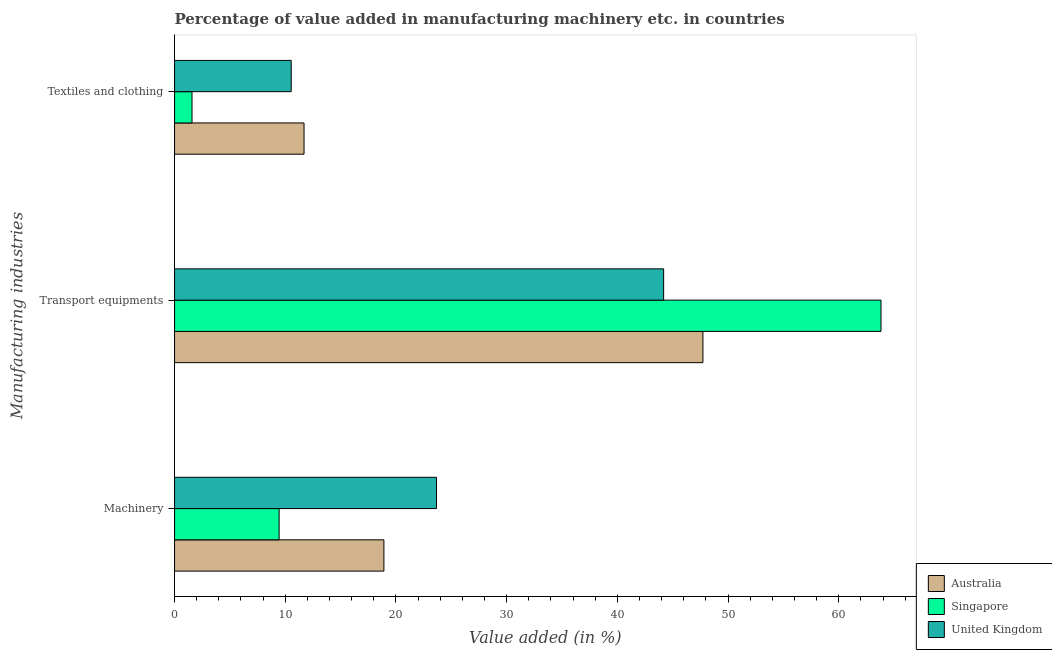How many different coloured bars are there?
Your answer should be compact. 3. How many groups of bars are there?
Provide a short and direct response. 3. How many bars are there on the 1st tick from the top?
Provide a short and direct response. 3. How many bars are there on the 1st tick from the bottom?
Your answer should be compact. 3. What is the label of the 1st group of bars from the top?
Offer a very short reply. Textiles and clothing. What is the value added in manufacturing machinery in United Kingdom?
Give a very brief answer. 23.66. Across all countries, what is the maximum value added in manufacturing textile and clothing?
Offer a very short reply. 11.7. Across all countries, what is the minimum value added in manufacturing transport equipments?
Offer a very short reply. 44.18. What is the total value added in manufacturing transport equipments in the graph?
Provide a short and direct response. 155.71. What is the difference between the value added in manufacturing machinery in Singapore and that in Australia?
Your answer should be compact. -9.47. What is the difference between the value added in manufacturing transport equipments in Singapore and the value added in manufacturing machinery in United Kingdom?
Ensure brevity in your answer.  40.15. What is the average value added in manufacturing transport equipments per country?
Your answer should be compact. 51.9. What is the difference between the value added in manufacturing textile and clothing and value added in manufacturing transport equipments in Singapore?
Your response must be concise. -62.23. What is the ratio of the value added in manufacturing machinery in Australia to that in United Kingdom?
Provide a short and direct response. 0.8. Is the value added in manufacturing transport equipments in Singapore less than that in United Kingdom?
Your answer should be very brief. No. What is the difference between the highest and the second highest value added in manufacturing textile and clothing?
Your response must be concise. 1.16. What is the difference between the highest and the lowest value added in manufacturing transport equipments?
Keep it short and to the point. 19.63. Is it the case that in every country, the sum of the value added in manufacturing machinery and value added in manufacturing transport equipments is greater than the value added in manufacturing textile and clothing?
Give a very brief answer. Yes. How many countries are there in the graph?
Make the answer very short. 3. Does the graph contain grids?
Make the answer very short. No. How many legend labels are there?
Give a very brief answer. 3. How are the legend labels stacked?
Provide a short and direct response. Vertical. What is the title of the graph?
Your response must be concise. Percentage of value added in manufacturing machinery etc. in countries. Does "Italy" appear as one of the legend labels in the graph?
Make the answer very short. No. What is the label or title of the X-axis?
Offer a terse response. Value added (in %). What is the label or title of the Y-axis?
Keep it short and to the point. Manufacturing industries. What is the Value added (in %) of Australia in Machinery?
Provide a succinct answer. 18.91. What is the Value added (in %) in Singapore in Machinery?
Offer a very short reply. 9.44. What is the Value added (in %) of United Kingdom in Machinery?
Make the answer very short. 23.66. What is the Value added (in %) of Australia in Transport equipments?
Give a very brief answer. 47.73. What is the Value added (in %) of Singapore in Transport equipments?
Give a very brief answer. 63.81. What is the Value added (in %) of United Kingdom in Transport equipments?
Offer a very short reply. 44.18. What is the Value added (in %) in Australia in Textiles and clothing?
Your response must be concise. 11.7. What is the Value added (in %) of Singapore in Textiles and clothing?
Offer a very short reply. 1.58. What is the Value added (in %) in United Kingdom in Textiles and clothing?
Your answer should be very brief. 10.54. Across all Manufacturing industries, what is the maximum Value added (in %) of Australia?
Your response must be concise. 47.73. Across all Manufacturing industries, what is the maximum Value added (in %) of Singapore?
Your response must be concise. 63.81. Across all Manufacturing industries, what is the maximum Value added (in %) of United Kingdom?
Your answer should be very brief. 44.18. Across all Manufacturing industries, what is the minimum Value added (in %) in Australia?
Give a very brief answer. 11.7. Across all Manufacturing industries, what is the minimum Value added (in %) in Singapore?
Your answer should be very brief. 1.58. Across all Manufacturing industries, what is the minimum Value added (in %) of United Kingdom?
Ensure brevity in your answer.  10.54. What is the total Value added (in %) of Australia in the graph?
Make the answer very short. 78.33. What is the total Value added (in %) in Singapore in the graph?
Provide a short and direct response. 74.83. What is the total Value added (in %) in United Kingdom in the graph?
Provide a short and direct response. 78.37. What is the difference between the Value added (in %) of Australia in Machinery and that in Transport equipments?
Your answer should be compact. -28.81. What is the difference between the Value added (in %) in Singapore in Machinery and that in Transport equipments?
Provide a short and direct response. -54.37. What is the difference between the Value added (in %) in United Kingdom in Machinery and that in Transport equipments?
Make the answer very short. -20.52. What is the difference between the Value added (in %) in Australia in Machinery and that in Textiles and clothing?
Provide a succinct answer. 7.22. What is the difference between the Value added (in %) in Singapore in Machinery and that in Textiles and clothing?
Keep it short and to the point. 7.87. What is the difference between the Value added (in %) in United Kingdom in Machinery and that in Textiles and clothing?
Offer a terse response. 13.12. What is the difference between the Value added (in %) of Australia in Transport equipments and that in Textiles and clothing?
Offer a terse response. 36.03. What is the difference between the Value added (in %) of Singapore in Transport equipments and that in Textiles and clothing?
Make the answer very short. 62.23. What is the difference between the Value added (in %) in United Kingdom in Transport equipments and that in Textiles and clothing?
Your answer should be very brief. 33.64. What is the difference between the Value added (in %) in Australia in Machinery and the Value added (in %) in Singapore in Transport equipments?
Offer a very short reply. -44.9. What is the difference between the Value added (in %) of Australia in Machinery and the Value added (in %) of United Kingdom in Transport equipments?
Ensure brevity in your answer.  -25.27. What is the difference between the Value added (in %) of Singapore in Machinery and the Value added (in %) of United Kingdom in Transport equipments?
Offer a very short reply. -34.73. What is the difference between the Value added (in %) in Australia in Machinery and the Value added (in %) in Singapore in Textiles and clothing?
Your answer should be compact. 17.33. What is the difference between the Value added (in %) of Australia in Machinery and the Value added (in %) of United Kingdom in Textiles and clothing?
Make the answer very short. 8.37. What is the difference between the Value added (in %) of Singapore in Machinery and the Value added (in %) of United Kingdom in Textiles and clothing?
Your answer should be compact. -1.09. What is the difference between the Value added (in %) in Australia in Transport equipments and the Value added (in %) in Singapore in Textiles and clothing?
Provide a short and direct response. 46.15. What is the difference between the Value added (in %) in Australia in Transport equipments and the Value added (in %) in United Kingdom in Textiles and clothing?
Give a very brief answer. 37.19. What is the difference between the Value added (in %) in Singapore in Transport equipments and the Value added (in %) in United Kingdom in Textiles and clothing?
Offer a very short reply. 53.27. What is the average Value added (in %) in Australia per Manufacturing industries?
Your answer should be compact. 26.11. What is the average Value added (in %) in Singapore per Manufacturing industries?
Make the answer very short. 24.94. What is the average Value added (in %) in United Kingdom per Manufacturing industries?
Your response must be concise. 26.12. What is the difference between the Value added (in %) of Australia and Value added (in %) of Singapore in Machinery?
Your answer should be compact. 9.47. What is the difference between the Value added (in %) in Australia and Value added (in %) in United Kingdom in Machinery?
Make the answer very short. -4.75. What is the difference between the Value added (in %) in Singapore and Value added (in %) in United Kingdom in Machinery?
Give a very brief answer. -14.22. What is the difference between the Value added (in %) of Australia and Value added (in %) of Singapore in Transport equipments?
Your answer should be compact. -16.09. What is the difference between the Value added (in %) of Australia and Value added (in %) of United Kingdom in Transport equipments?
Your response must be concise. 3.55. What is the difference between the Value added (in %) in Singapore and Value added (in %) in United Kingdom in Transport equipments?
Provide a short and direct response. 19.63. What is the difference between the Value added (in %) in Australia and Value added (in %) in Singapore in Textiles and clothing?
Ensure brevity in your answer.  10.12. What is the difference between the Value added (in %) of Australia and Value added (in %) of United Kingdom in Textiles and clothing?
Provide a succinct answer. 1.16. What is the difference between the Value added (in %) in Singapore and Value added (in %) in United Kingdom in Textiles and clothing?
Make the answer very short. -8.96. What is the ratio of the Value added (in %) in Australia in Machinery to that in Transport equipments?
Give a very brief answer. 0.4. What is the ratio of the Value added (in %) of Singapore in Machinery to that in Transport equipments?
Your answer should be compact. 0.15. What is the ratio of the Value added (in %) of United Kingdom in Machinery to that in Transport equipments?
Your answer should be very brief. 0.54. What is the ratio of the Value added (in %) in Australia in Machinery to that in Textiles and clothing?
Keep it short and to the point. 1.62. What is the ratio of the Value added (in %) of Singapore in Machinery to that in Textiles and clothing?
Your answer should be compact. 5.99. What is the ratio of the Value added (in %) of United Kingdom in Machinery to that in Textiles and clothing?
Your response must be concise. 2.25. What is the ratio of the Value added (in %) of Australia in Transport equipments to that in Textiles and clothing?
Your answer should be very brief. 4.08. What is the ratio of the Value added (in %) in Singapore in Transport equipments to that in Textiles and clothing?
Your answer should be very brief. 40.46. What is the ratio of the Value added (in %) in United Kingdom in Transport equipments to that in Textiles and clothing?
Your answer should be compact. 4.19. What is the difference between the highest and the second highest Value added (in %) of Australia?
Your answer should be very brief. 28.81. What is the difference between the highest and the second highest Value added (in %) of Singapore?
Keep it short and to the point. 54.37. What is the difference between the highest and the second highest Value added (in %) of United Kingdom?
Give a very brief answer. 20.52. What is the difference between the highest and the lowest Value added (in %) of Australia?
Your answer should be very brief. 36.03. What is the difference between the highest and the lowest Value added (in %) of Singapore?
Offer a terse response. 62.23. What is the difference between the highest and the lowest Value added (in %) in United Kingdom?
Provide a short and direct response. 33.64. 